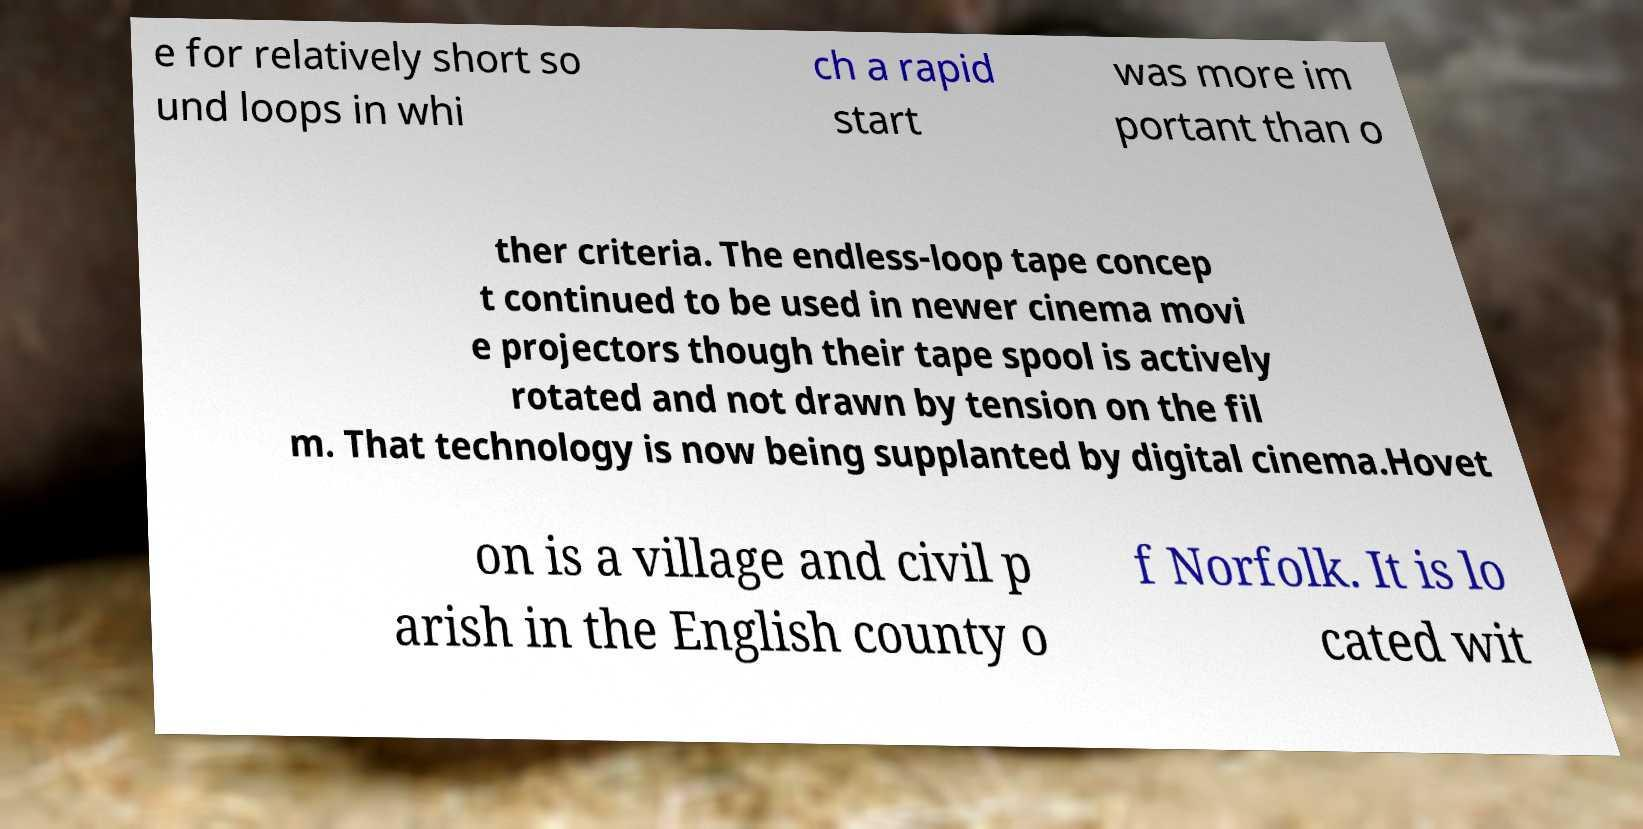Please identify and transcribe the text found in this image. e for relatively short so und loops in whi ch a rapid start was more im portant than o ther criteria. The endless-loop tape concep t continued to be used in newer cinema movi e projectors though their tape spool is actively rotated and not drawn by tension on the fil m. That technology is now being supplanted by digital cinema.Hovet on is a village and civil p arish in the English county o f Norfolk. It is lo cated wit 